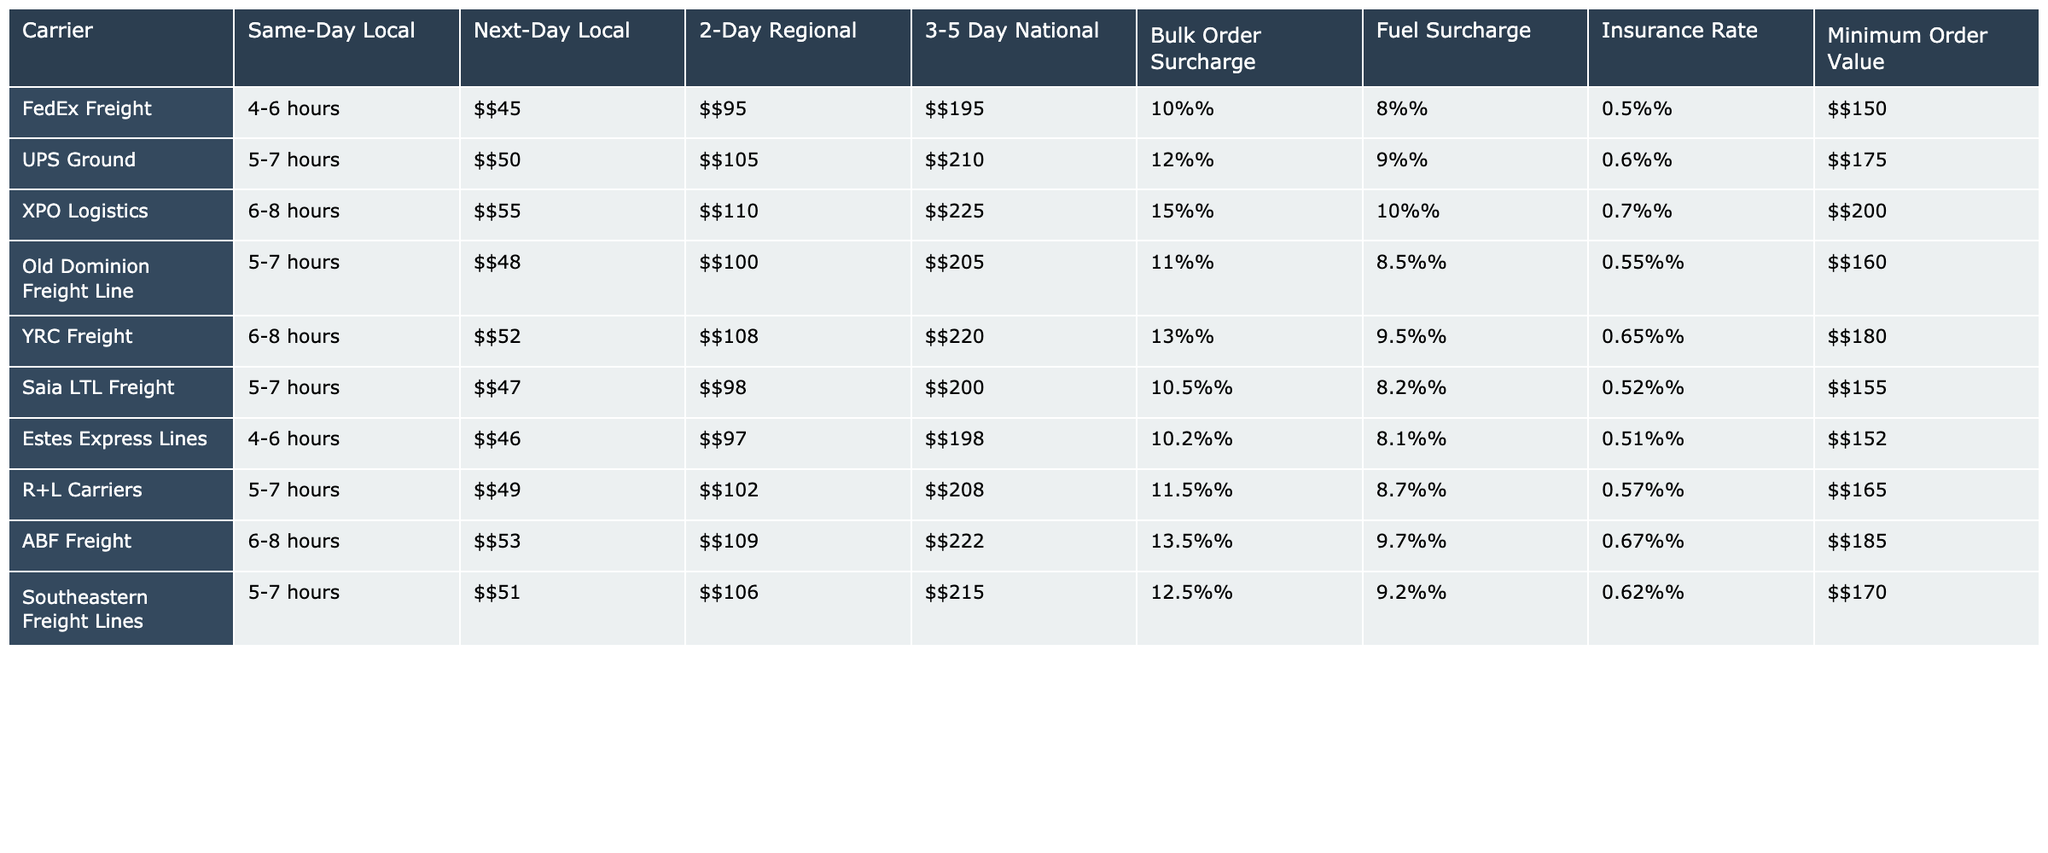What is the delivery time for FedEx Freight for Same-Day Local? The table shows that the delivery time for FedEx Freight for Same-Day Local is 4-6 hours.
Answer: 4-6 hours Which carrier has the lowest Next-Day Local cost? By examining the 'Next-Day Local' column, Old Dominion Freight Line has the lowest cost at $100.
Answer: Old Dominion Freight Line What is the average minimum order value across all carriers? The minimum order values are $150, $175, $200, $160, $180, $155, $152, $165, $185, and $170. Adding these gives a total of $1692, and dividing by 10 (the number of carriers) gives an average of $169.20.
Answer: $169.20 Is the fuel surcharge for UPS Ground higher than that of Estes Express Lines? The fuel surcharge for UPS Ground is 9% while Estes Express Lines has a surcharge of 8.1%. Since 9% is greater than 8.1%, the statement is true.
Answer: Yes Which carrier has the highest 3-5 Day National cost? Looking at the '3-5 Day National' column, XPO Logistics has the highest cost at $225.
Answer: XPO Logistics What is the difference in cost between the highest and lowest 2-Day Regional shipping costs? The highest cost for 2-Day Regional is $225 (XPO Logistics) and the lowest is $95 (FedEx Freight). The difference is $225 - $95 = $130.
Answer: $130 Is there any carrier that offers a Same-Day Local delivery time of 5-7 hours? The table lists UPS Ground, Old Dominion Freight Line, Saia LTL Freight, and Southeastern Freight Lines, all of which have Same-Day Local delivery times of 5-7 hours. Therefore, there are carriers that fit this criterion.
Answer: Yes What is the overall trend in Bulk Order Surcharge percentages among the carriers? The table shows percentages ranging from 10% to 15%. The trend indicates that most carriers have a surcharge around 10-12%, with some, like XPO Logistics and ABF Freight, being higher at 15% and 13.5%, respectively.
Answer: Generally around 10-12%, with some higher Which carrier would be the best option for a bulk order with low fuel surcharge and minimum order value? Saia LTL Freight has a competitive Bulk Order Surcharge of 10.5%, a fuel surcharge of 8.2%, and a minimum order value of $155.
Answer: Saia LTL Freight What is the insurance rate for the carrier with the highest 2-Day Regional cost? XPO Logistics has the highest 2-Day Regional cost of $225 and the insurance rate listed is 0.7%.
Answer: 0.7% 